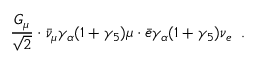Convert formula to latex. <formula><loc_0><loc_0><loc_500><loc_500>\frac { G _ { \mu } } { \sqrt { 2 } } \cdot \bar { \nu } _ { \mu } \gamma _ { \alpha } ( 1 + \gamma _ { 5 } ) \mu \cdot \bar { e } \gamma _ { \alpha } ( 1 + \gamma _ { 5 } ) \nu _ { e } \, .</formula> 